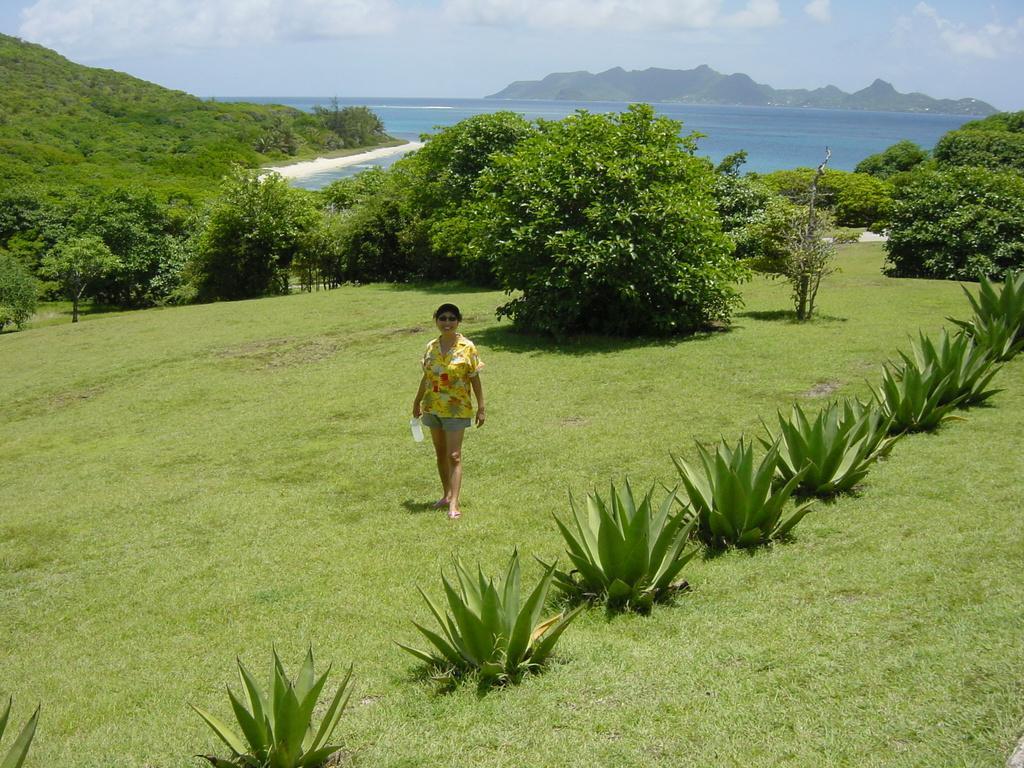Could you give a brief overview of what you see in this image? There is a person standing on the ground. Here we can see plants, grass, trees, and water. In the background we can see a mountain and sky with clouds. 